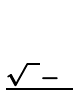Convert formula to latex. <formula><loc_0><loc_0><loc_500><loc_500>\begin{matrix} 1 \\ \frac { \sqrt { 5 } - 1 } { 2 } \end{matrix}</formula> 